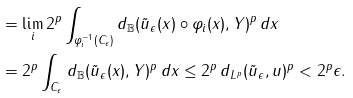Convert formula to latex. <formula><loc_0><loc_0><loc_500><loc_500>& = \lim _ { i } 2 ^ { p } \int _ { \varphi _ { i } ^ { - 1 } ( C _ { \epsilon } ) } d _ { \mathbb { B } } ( \tilde { u } _ { \epsilon } ( x ) \circ \varphi _ { i } ( x ) , Y ) ^ { p } \, d x \\ & = 2 ^ { p } \int _ { C _ { \epsilon } } d _ { \mathbb { B } } ( \tilde { u } _ { \epsilon } ( x ) , Y ) ^ { p } \, d x \leq 2 ^ { p } \, d _ { L ^ { p } } ( \tilde { u } _ { \epsilon } , u ) ^ { p } < 2 ^ { p } \epsilon .</formula> 